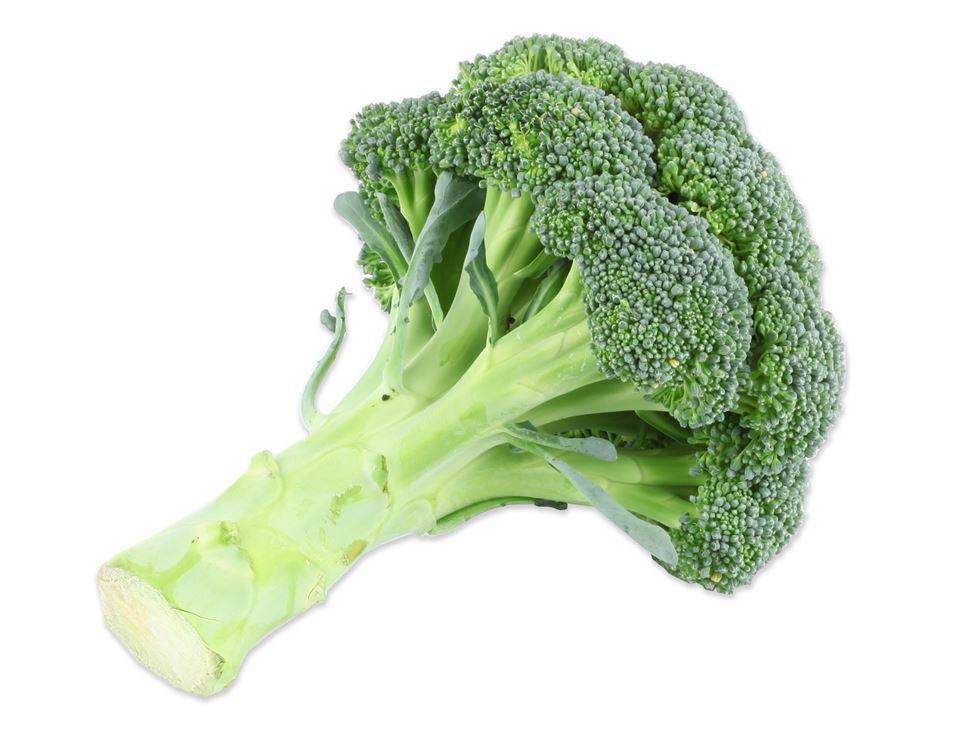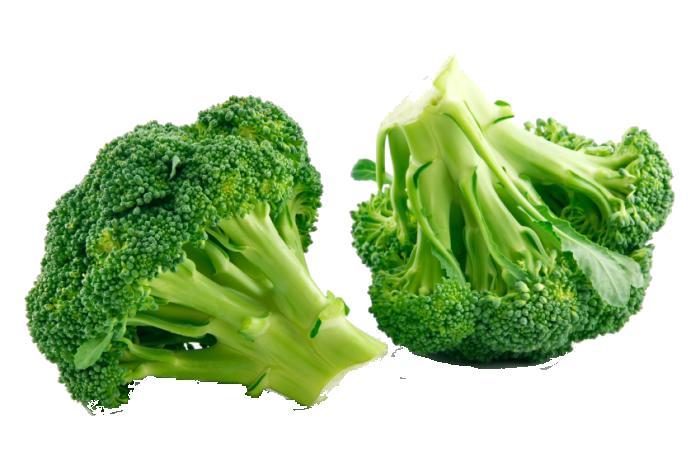The first image is the image on the left, the second image is the image on the right. Evaluate the accuracy of this statement regarding the images: "All images are on a plain white background.". Is it true? Answer yes or no. Yes. The first image is the image on the left, the second image is the image on the right. For the images displayed, is the sentence "there are 3 bunches of broccoli against a white background" factually correct? Answer yes or no. Yes. 